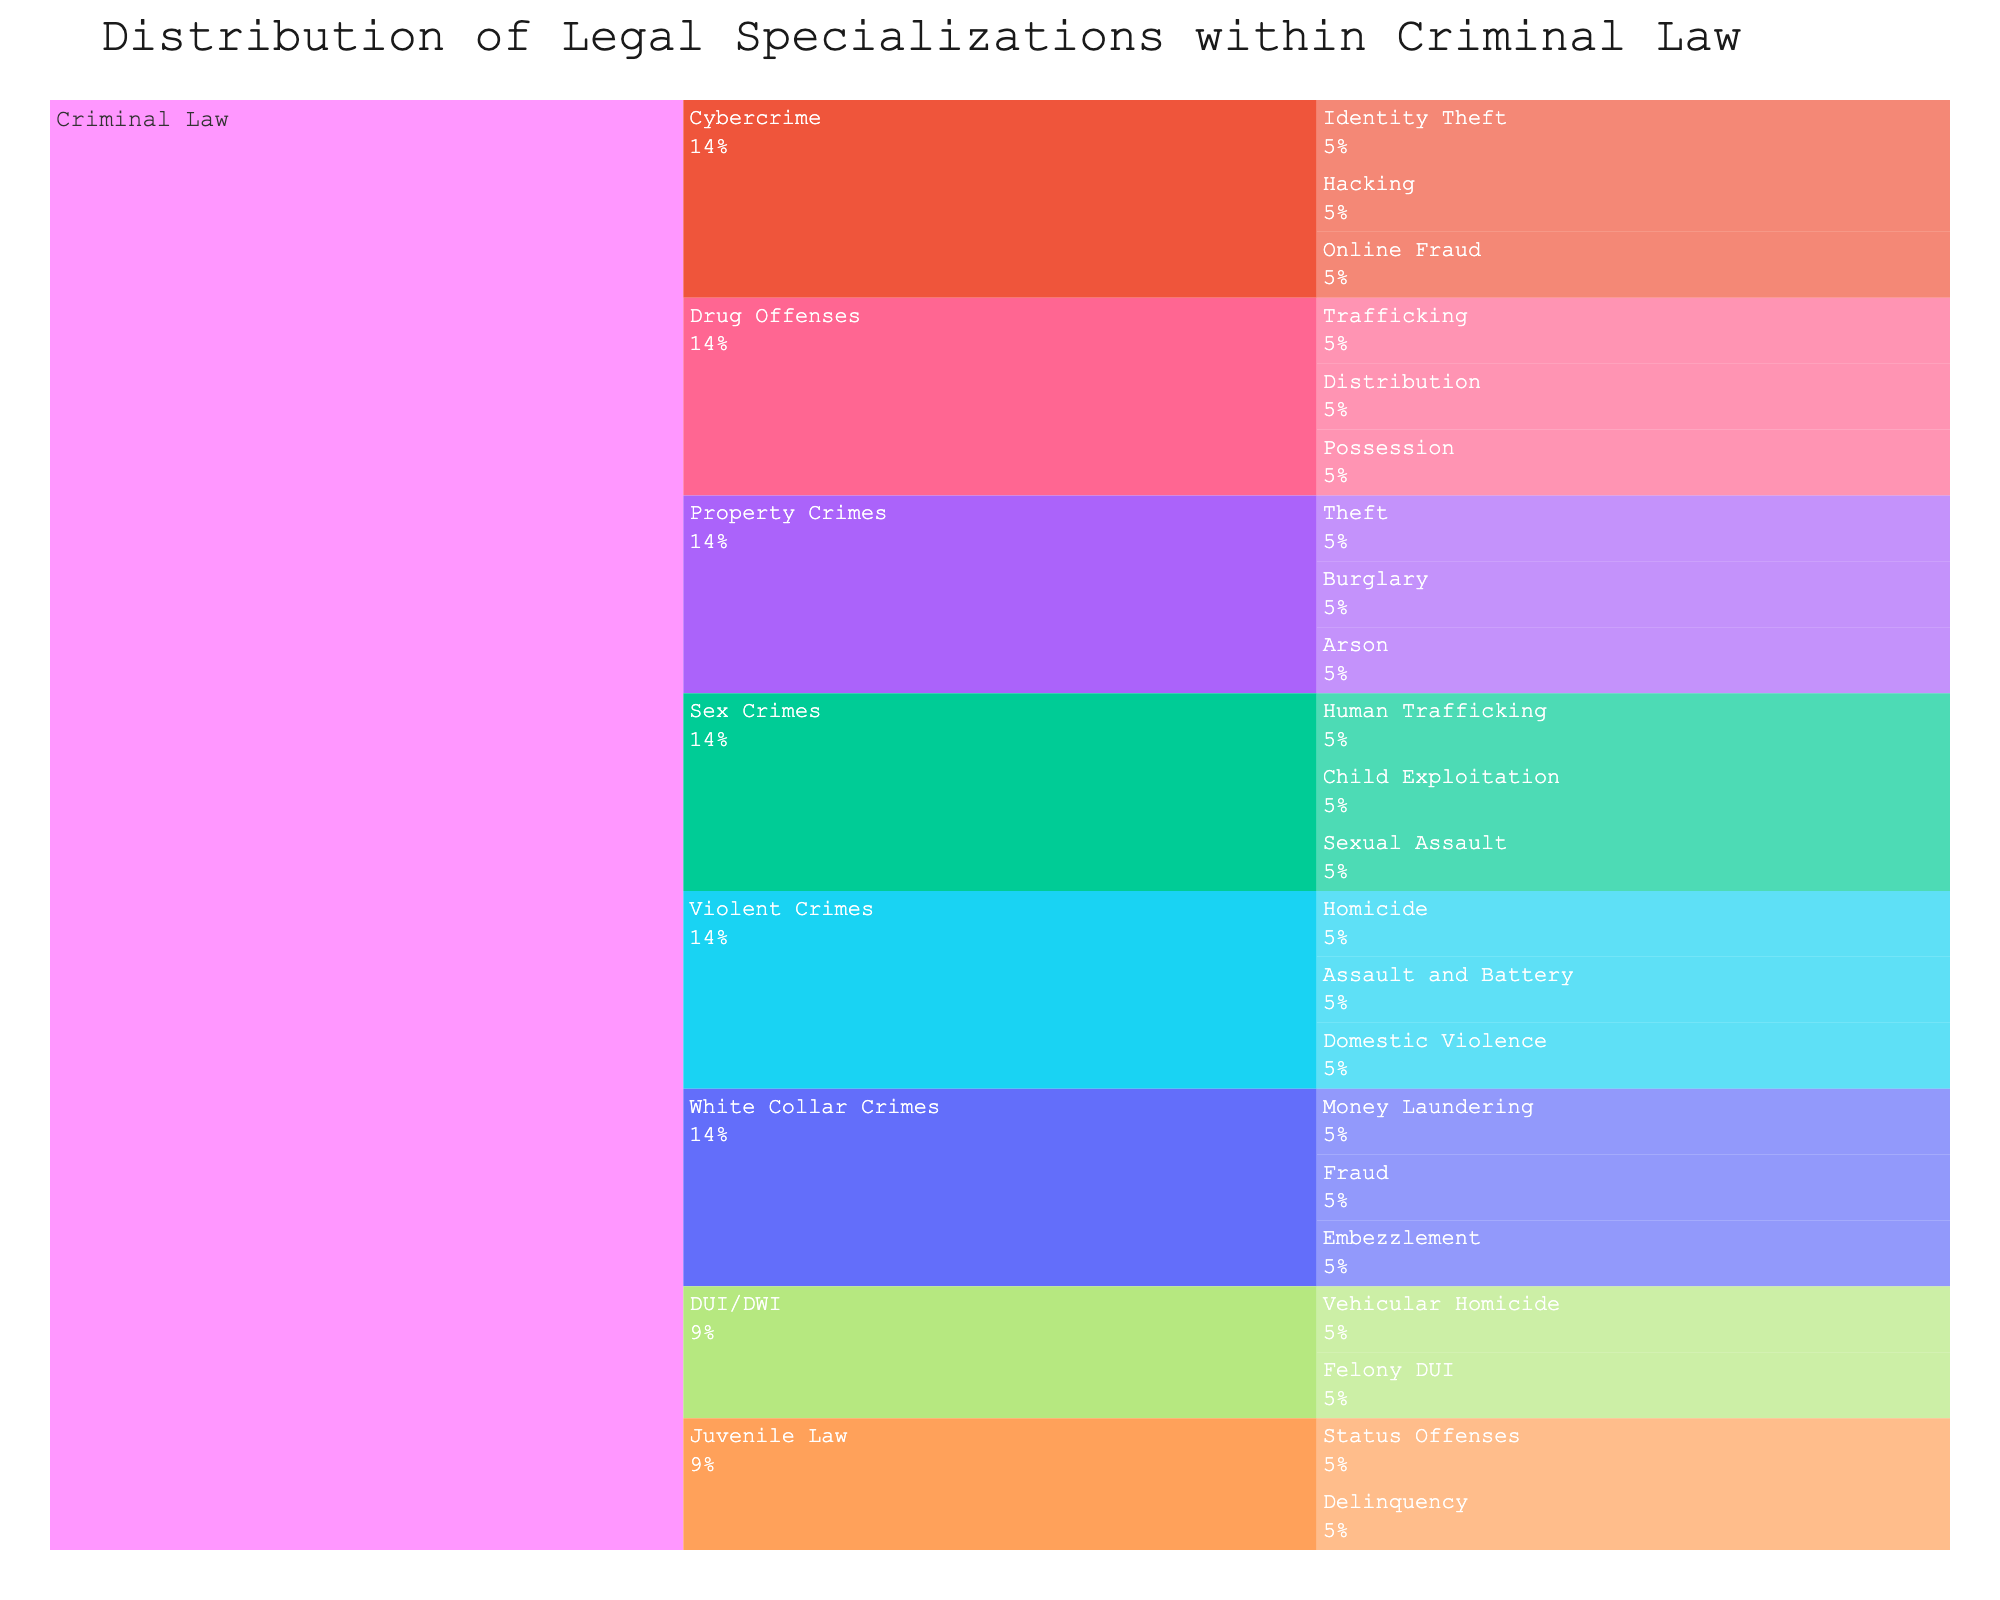What's the title of the icicle chart? The title is usually displayed at the top of the chart and directly provides the main subject of the visualization. The title for this chart is "Distribution of Legal Specializations within Criminal Law".
Answer: Distribution of Legal Specializations within Criminal Law Which subcategory under Criminal Law has the highest number of niche areas? To determine this, count the niche areas listed under each subcategory. Comparing these counts will show that "Violent Crimes" has the most with three niches: Homicide, Assault and Battery, and Domestic Violence.
Answer: Violent Crimes How many total subcategories are there under Criminal Law? Each unique subcategory counts as one. By listing them out: Violent Crimes, Property Crimes, White Collar Crimes, Drug Offenses, Cybercrime, Sex Crimes, DUI/DWI, and Juvenile Law, we see there are 8 total subcategories.
Answer: 8 Which niche area under Drug Offenses might require understanding international law? Each niche under Drug Offenses should be considered. Trafficking typically involves interstate and international elements, necessitating knowledge of international law.
Answer: Trafficking Compare the subcategories of Property Crimes and White Collar Crimes. Which has more niches? Count the niches under each subcategory: Property Crimes (Burglary, Theft, Arson) has three niches, while White Collar Crimes (Fraud, Embezzlement, Money Laundering) also has three. Both have the same number of niches.
Answer: Equal, both have 3 niches Identify the difference in the number of niches between Violent Crimes and Cybercrime. Calculate the number of niches for both: Violent Crimes has 3 niches, and Cybercrime also has 3 niches (Hacking, Identity Theft, Online Fraud). The difference is zero.
Answer: 0 Which subcategory includes Vehicular Homicide? Examine the chart to see which subcategory highlights Vehicular Homicide: DUI/DWI includes it along with Felony DUI.
Answer: DUI/DWI Calculate the total number of niche areas depicted in the icicle chart. Sum the niches for all subcategories: Violent Crimes (3) + Property Crimes (3) + White Collar Crimes (3) + Drug Offenses (3) + Cybercrime (3) + Sex Crimes (3) + DUI/DWI (2) + Juvenile Law (2). The total is 22.
Answer: 22 Between Domestic Violence and Online Fraud, which falls under the Cybercrime category? By checking the subcategories the niches belong to: Online Fraud falls under Cybercrime, while Domestic Violence falls under Violent Crimes.
Answer: Online Fraud Which subcategory might deal with high-profile financial investigations? Examine the subcategories and their niches: White Collar Crimes, including Fraud, Embezzlement, and Money Laundering, is likely to deal with high-profile financial investigations.
Answer: White Collar Crimes 